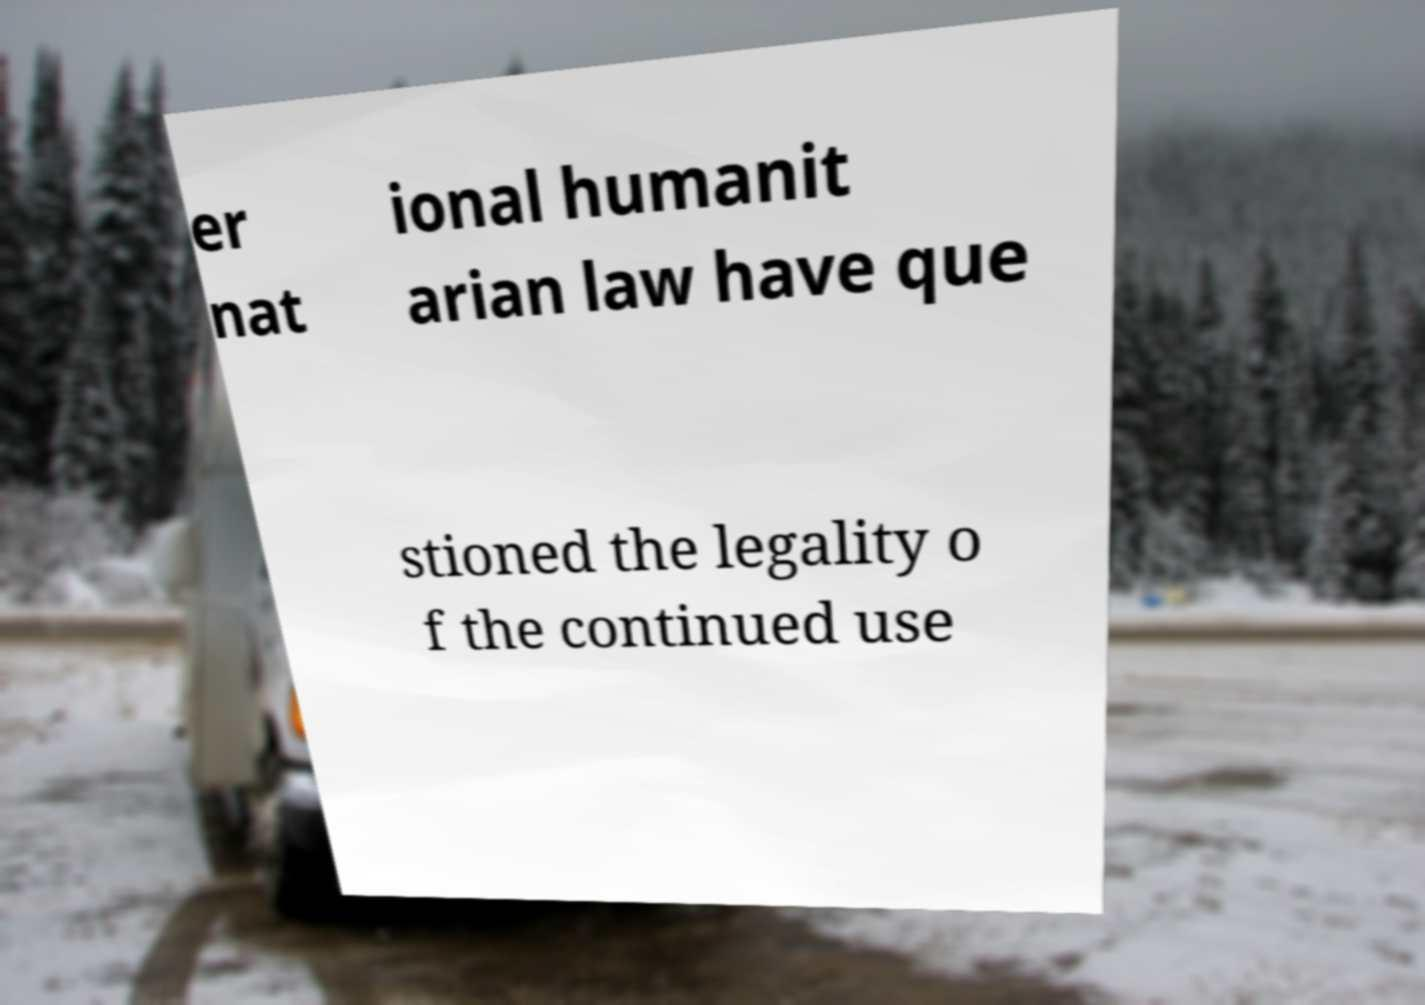There's text embedded in this image that I need extracted. Can you transcribe it verbatim? er nat ional humanit arian law have que stioned the legality o f the continued use 